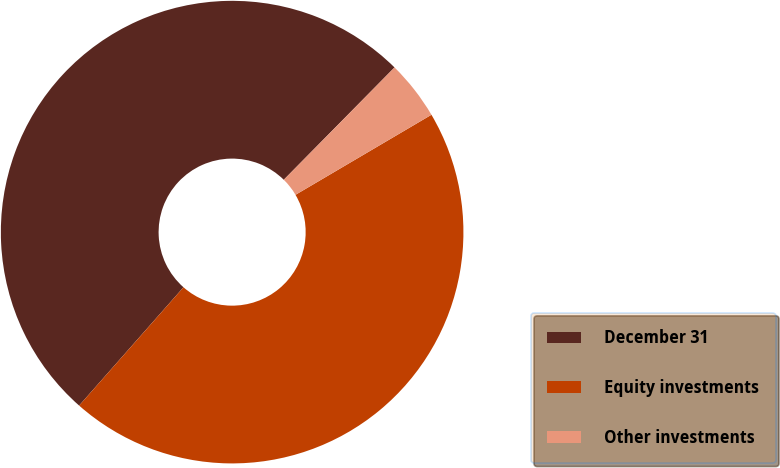Convert chart to OTSL. <chart><loc_0><loc_0><loc_500><loc_500><pie_chart><fcel>December 31<fcel>Equity investments<fcel>Other investments<nl><fcel>50.88%<fcel>44.97%<fcel>4.14%<nl></chart> 